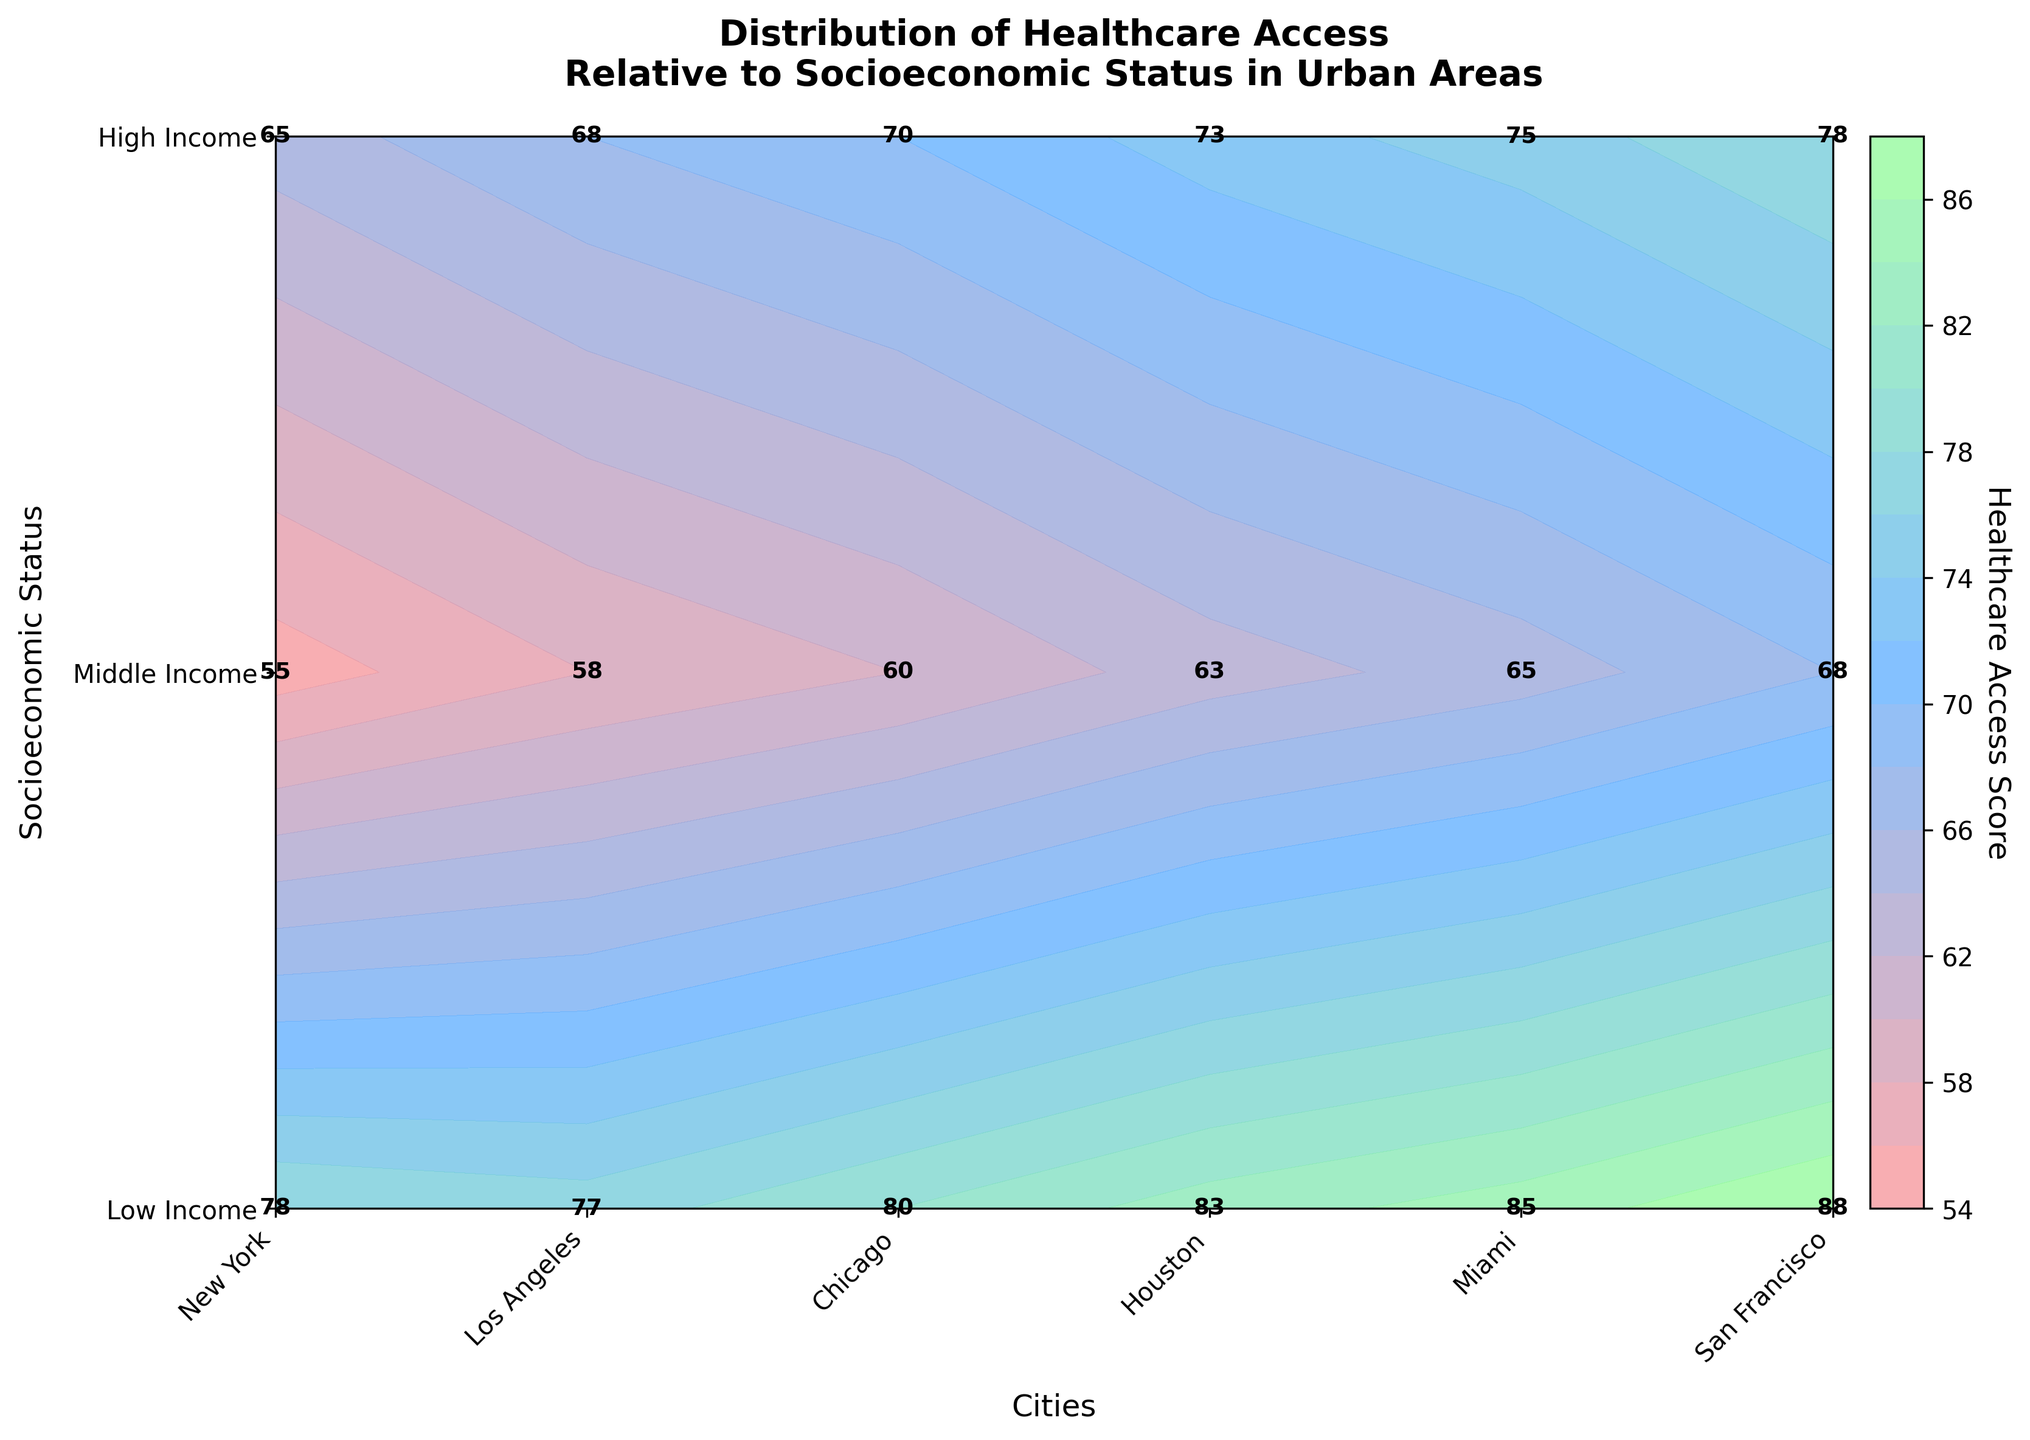What is the title of the plot? The title is displayed at the top of the figure, summarizing the depicted data. The text reads, "Distribution of Healthcare Access Relative to Socioeconomic Status in Urban Areas."
Answer: Distribution of Healthcare Access Relative to Socioeconomic Status in Urban Areas Which city shows the highest healthcare access score for high income groups? Locate the "High Income" row on the y-axis and find the highest contour label on this row. The highest value is marked in the "San Francisco" column, which is 88.
Answer: San Francisco What is the difference in healthcare access scores between low income and high income groups in Los Angeles? Examine the values under "Los Angeles" for both "Low Income" and "High Income." The access scores are 60 and 80, respectively. Subtract the lower score from the higher one: 80 - 60 = 20.
Answer: 20 Which city has the most balanced healthcare access scores across all income levels? "Balanced" implies that the differences between scores for low, middle, and high income groups are minimal. Checking the values, Miami shows scores of 63, 73, and 83—very close distances between these values (10 units apart).
Answer: Miami Is there any city where the healthcare access decreases as socioeconomic status increases? Check each city's scores across the income levels. All cities show increasing scores from low to high income; thus, there is no city where the access decreases as socioeconomic status increases.
Answer: No What are the healthcare access scores for middle income groups in Chicago and New York? Look at the "Middle Income" row and locate the columns for Chicago and New York. The scores are 65 for Chicago and 75 for New York.
Answer: 65 for Chicago and 75 for New York Which income group generally has the highest healthcare access scores across all cities? By observing the y-axis labels and contour levels, it is clear that the "High Income" group consistently has the highest scores across all cities.
Answer: High Income What's the average healthcare access score for high income groups across all cities? Sum the high income scores for all cities: 85 (New York) + 80 (Los Angeles) + 78 (Chicago) + 77 (Houston) + 83 (Miami) + 88 (San Francisco) = 491. Divide by the number of cities: 491 / 6 ≈ 81.83.
Answer: Approximately 81.83 Which city has the lowest healthcare access score for any income group, and what is that score? Identify the lowest value across all contour labels. It is 55 in the "Low Income" row and "Chicago" column.
Answer: Chicago, 55 How much higher is the healthcare access score for high income in San Francisco compared to middle income in the same city? Find San Francisco's scores for "High Income" (88) and "Middle Income" (78). Subtract the middle income score from the high income score: 88 - 78 = 10.
Answer: 10 